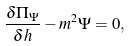Convert formula to latex. <formula><loc_0><loc_0><loc_500><loc_500>\frac { \delta \Pi _ { \Psi } } { \delta h } - m ^ { 2 } \Psi = 0 ,</formula> 